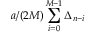<formula> <loc_0><loc_0><loc_500><loc_500>a / ( 2 M ) \sum _ { i = 0 } ^ { M - 1 } \Delta _ { n - i }</formula> 